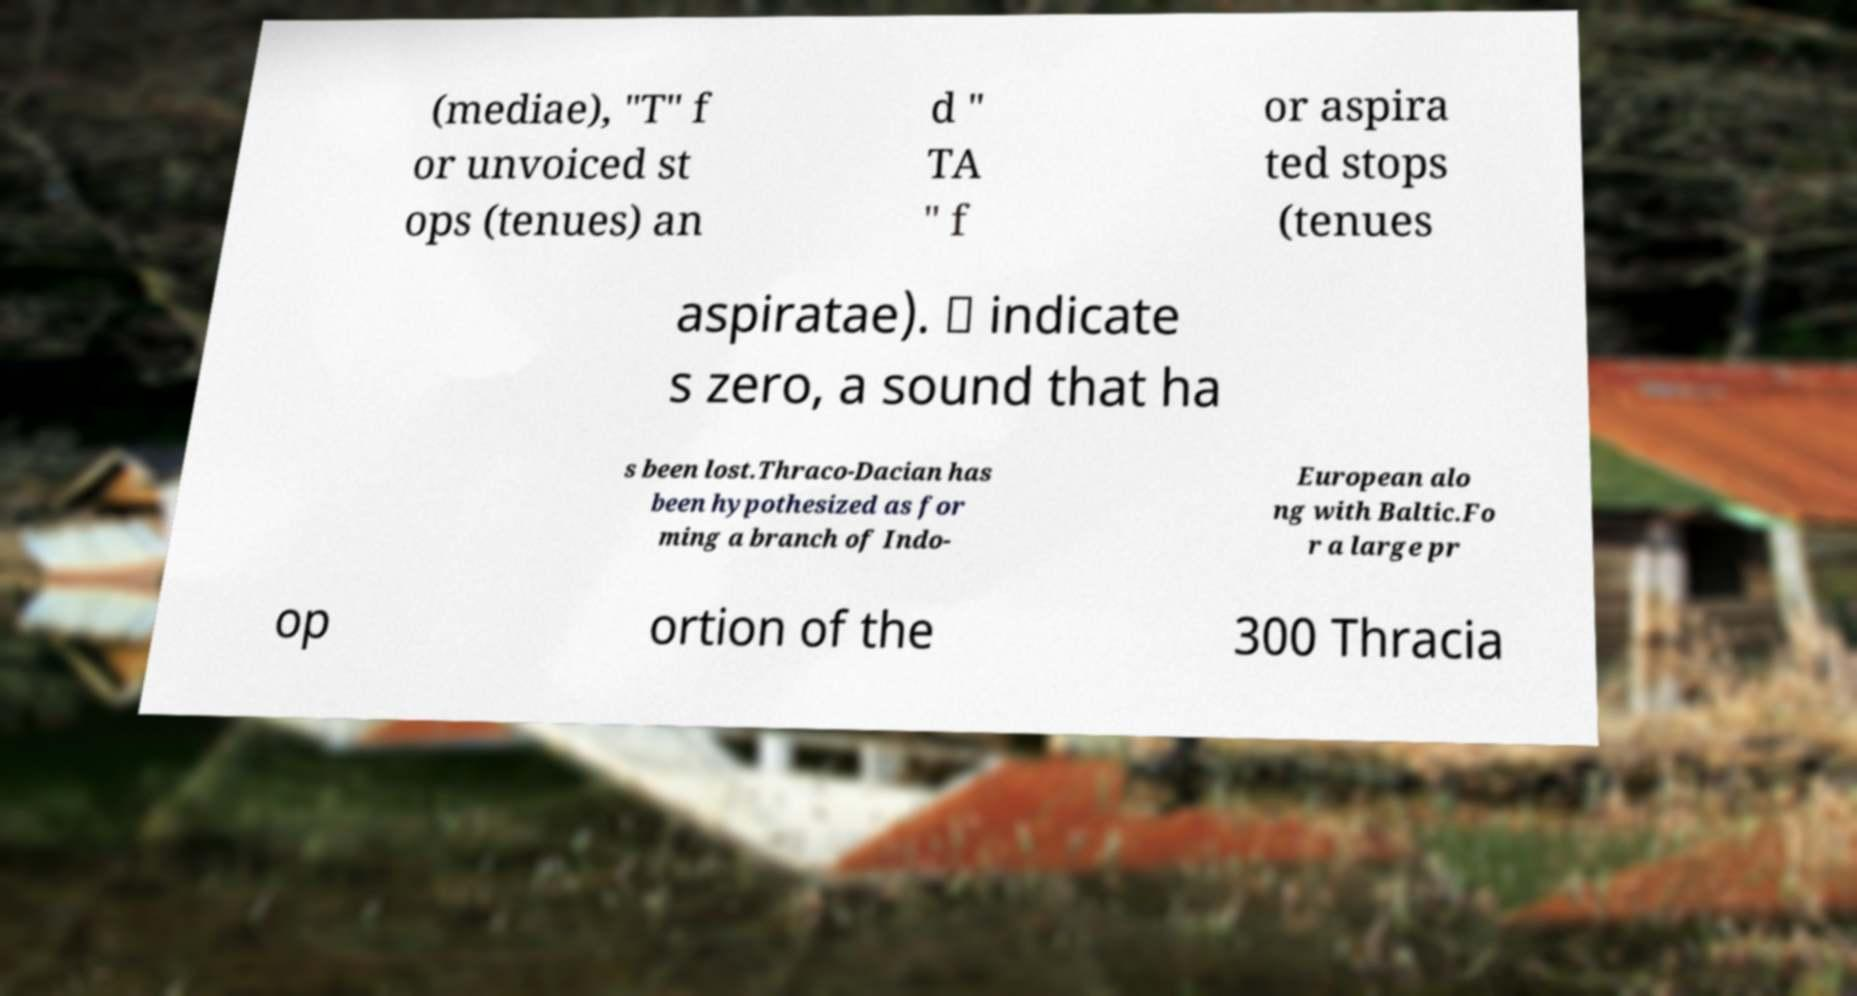Can you accurately transcribe the text from the provided image for me? (mediae), "T" f or unvoiced st ops (tenues) an d " TA " f or aspira ted stops (tenues aspiratae). ∅ indicate s zero, a sound that ha s been lost.Thraco-Dacian has been hypothesized as for ming a branch of Indo- European alo ng with Baltic.Fo r a large pr op ortion of the 300 Thracia 